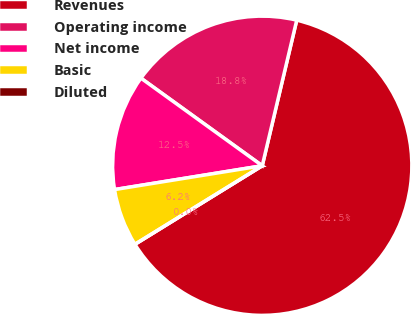<chart> <loc_0><loc_0><loc_500><loc_500><pie_chart><fcel>Revenues<fcel>Operating income<fcel>Net income<fcel>Basic<fcel>Diluted<nl><fcel>62.5%<fcel>18.75%<fcel>12.5%<fcel>6.25%<fcel>0.0%<nl></chart> 